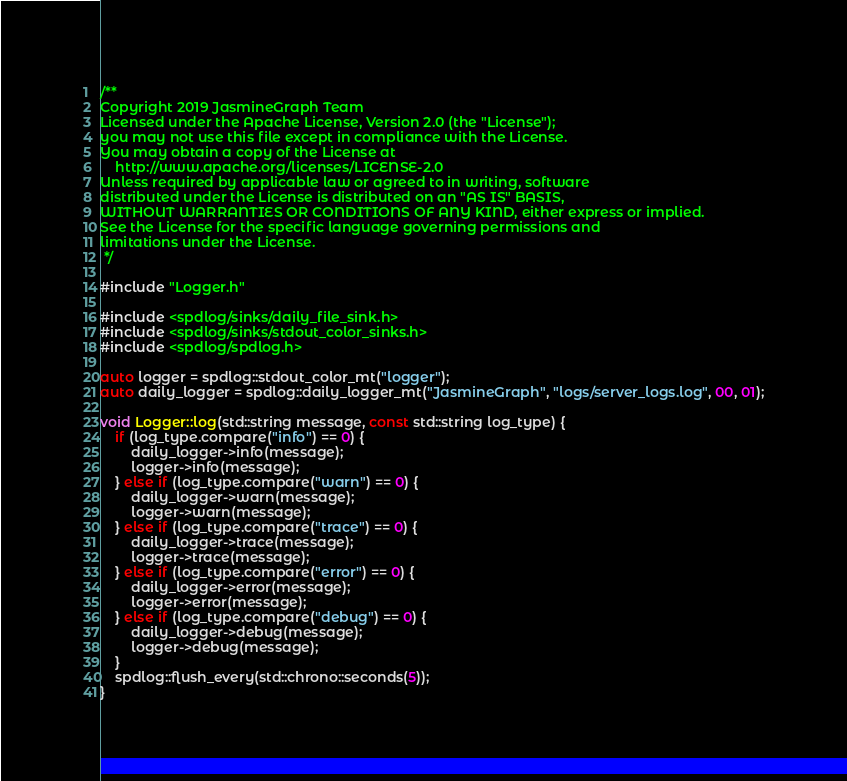Convert code to text. <code><loc_0><loc_0><loc_500><loc_500><_C++_>/**
Copyright 2019 JasmineGraph Team
Licensed under the Apache License, Version 2.0 (the "License");
you may not use this file except in compliance with the License.
You may obtain a copy of the License at
    http://www.apache.org/licenses/LICENSE-2.0
Unless required by applicable law or agreed to in writing, software
distributed under the License is distributed on an "AS IS" BASIS,
WITHOUT WARRANTIES OR CONDITIONS OF ANY KIND, either express or implied.
See the License for the specific language governing permissions and
limitations under the License.
 */

#include "Logger.h"

#include <spdlog/sinks/daily_file_sink.h>
#include <spdlog/sinks/stdout_color_sinks.h>
#include <spdlog/spdlog.h>

auto logger = spdlog::stdout_color_mt("logger");
auto daily_logger = spdlog::daily_logger_mt("JasmineGraph", "logs/server_logs.log", 00, 01);

void Logger::log(std::string message, const std::string log_type) {
    if (log_type.compare("info") == 0) {
        daily_logger->info(message);
        logger->info(message);
    } else if (log_type.compare("warn") == 0) {
        daily_logger->warn(message);
        logger->warn(message);
    } else if (log_type.compare("trace") == 0) {
        daily_logger->trace(message);
        logger->trace(message);
    } else if (log_type.compare("error") == 0) {
        daily_logger->error(message);
        logger->error(message);
    } else if (log_type.compare("debug") == 0) {
        daily_logger->debug(message);
        logger->debug(message);
    }
    spdlog::flush_every(std::chrono::seconds(5));
}
</code> 